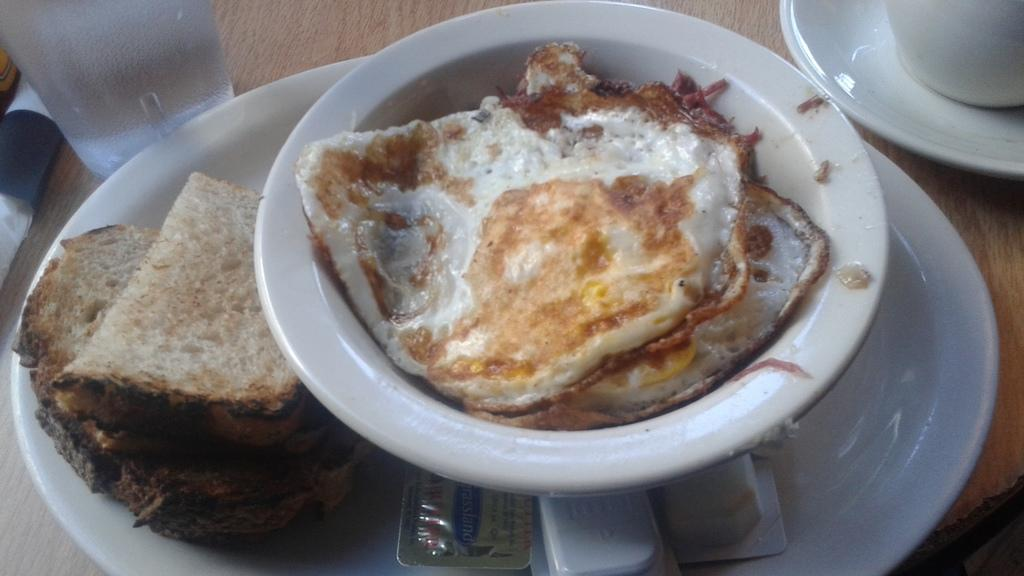What piece of furniture is present in the image? There is a table in the image. What items are placed on the table? There are plates, a bowl, a glass, a cup, tablets, and bread on the table. What type of food can be seen on the table? There is food placed on the table. What type of brick is used to build the table in the image? There is no mention of a brick or any building materials in the image; it features a table with various items placed on it. How does the cough affect the food on the table in the image? There is no cough or any indication of a health issue in the image; it simply shows a table with food and other items. 